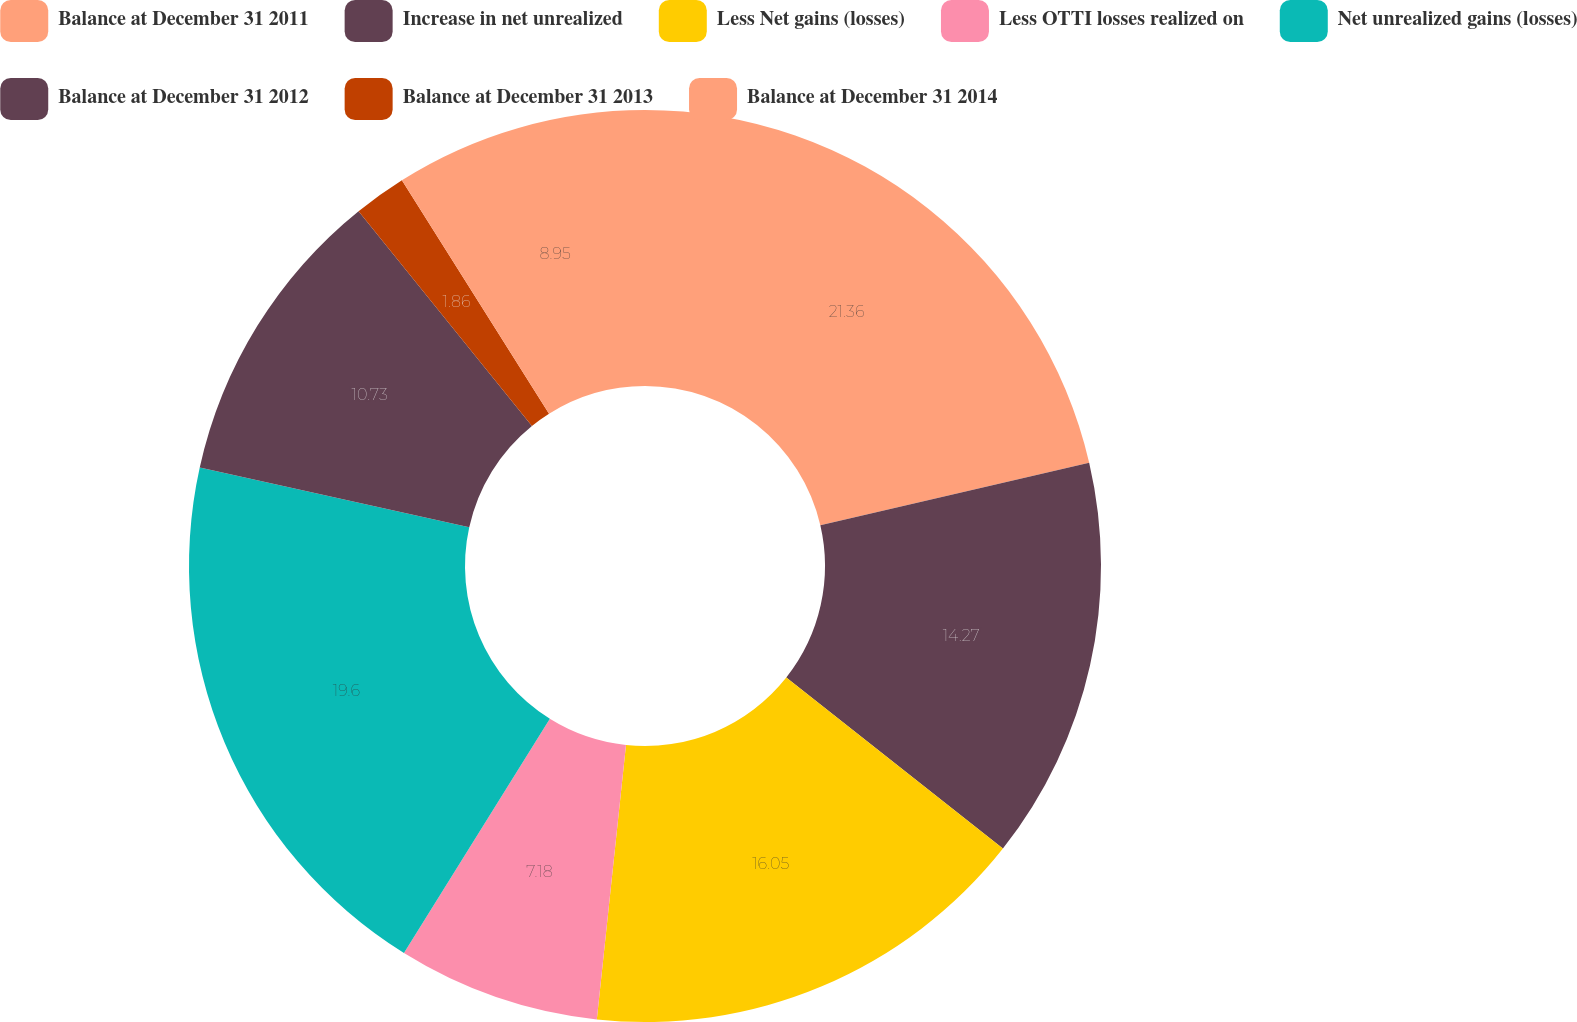Convert chart to OTSL. <chart><loc_0><loc_0><loc_500><loc_500><pie_chart><fcel>Balance at December 31 2011<fcel>Increase in net unrealized<fcel>Less Net gains (losses)<fcel>Less OTTI losses realized on<fcel>Net unrealized gains (losses)<fcel>Balance at December 31 2012<fcel>Balance at December 31 2013<fcel>Balance at December 31 2014<nl><fcel>21.37%<fcel>14.27%<fcel>16.05%<fcel>7.18%<fcel>19.6%<fcel>10.73%<fcel>1.86%<fcel>8.95%<nl></chart> 